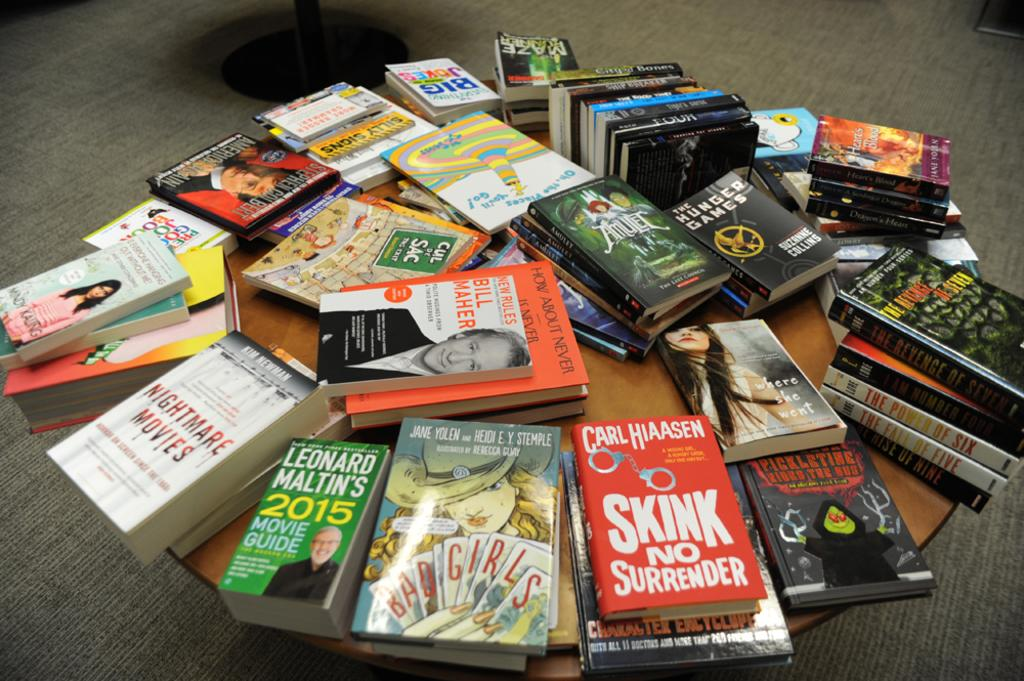<image>
Present a compact description of the photo's key features. A collection of books including a movie guide for 2015. 